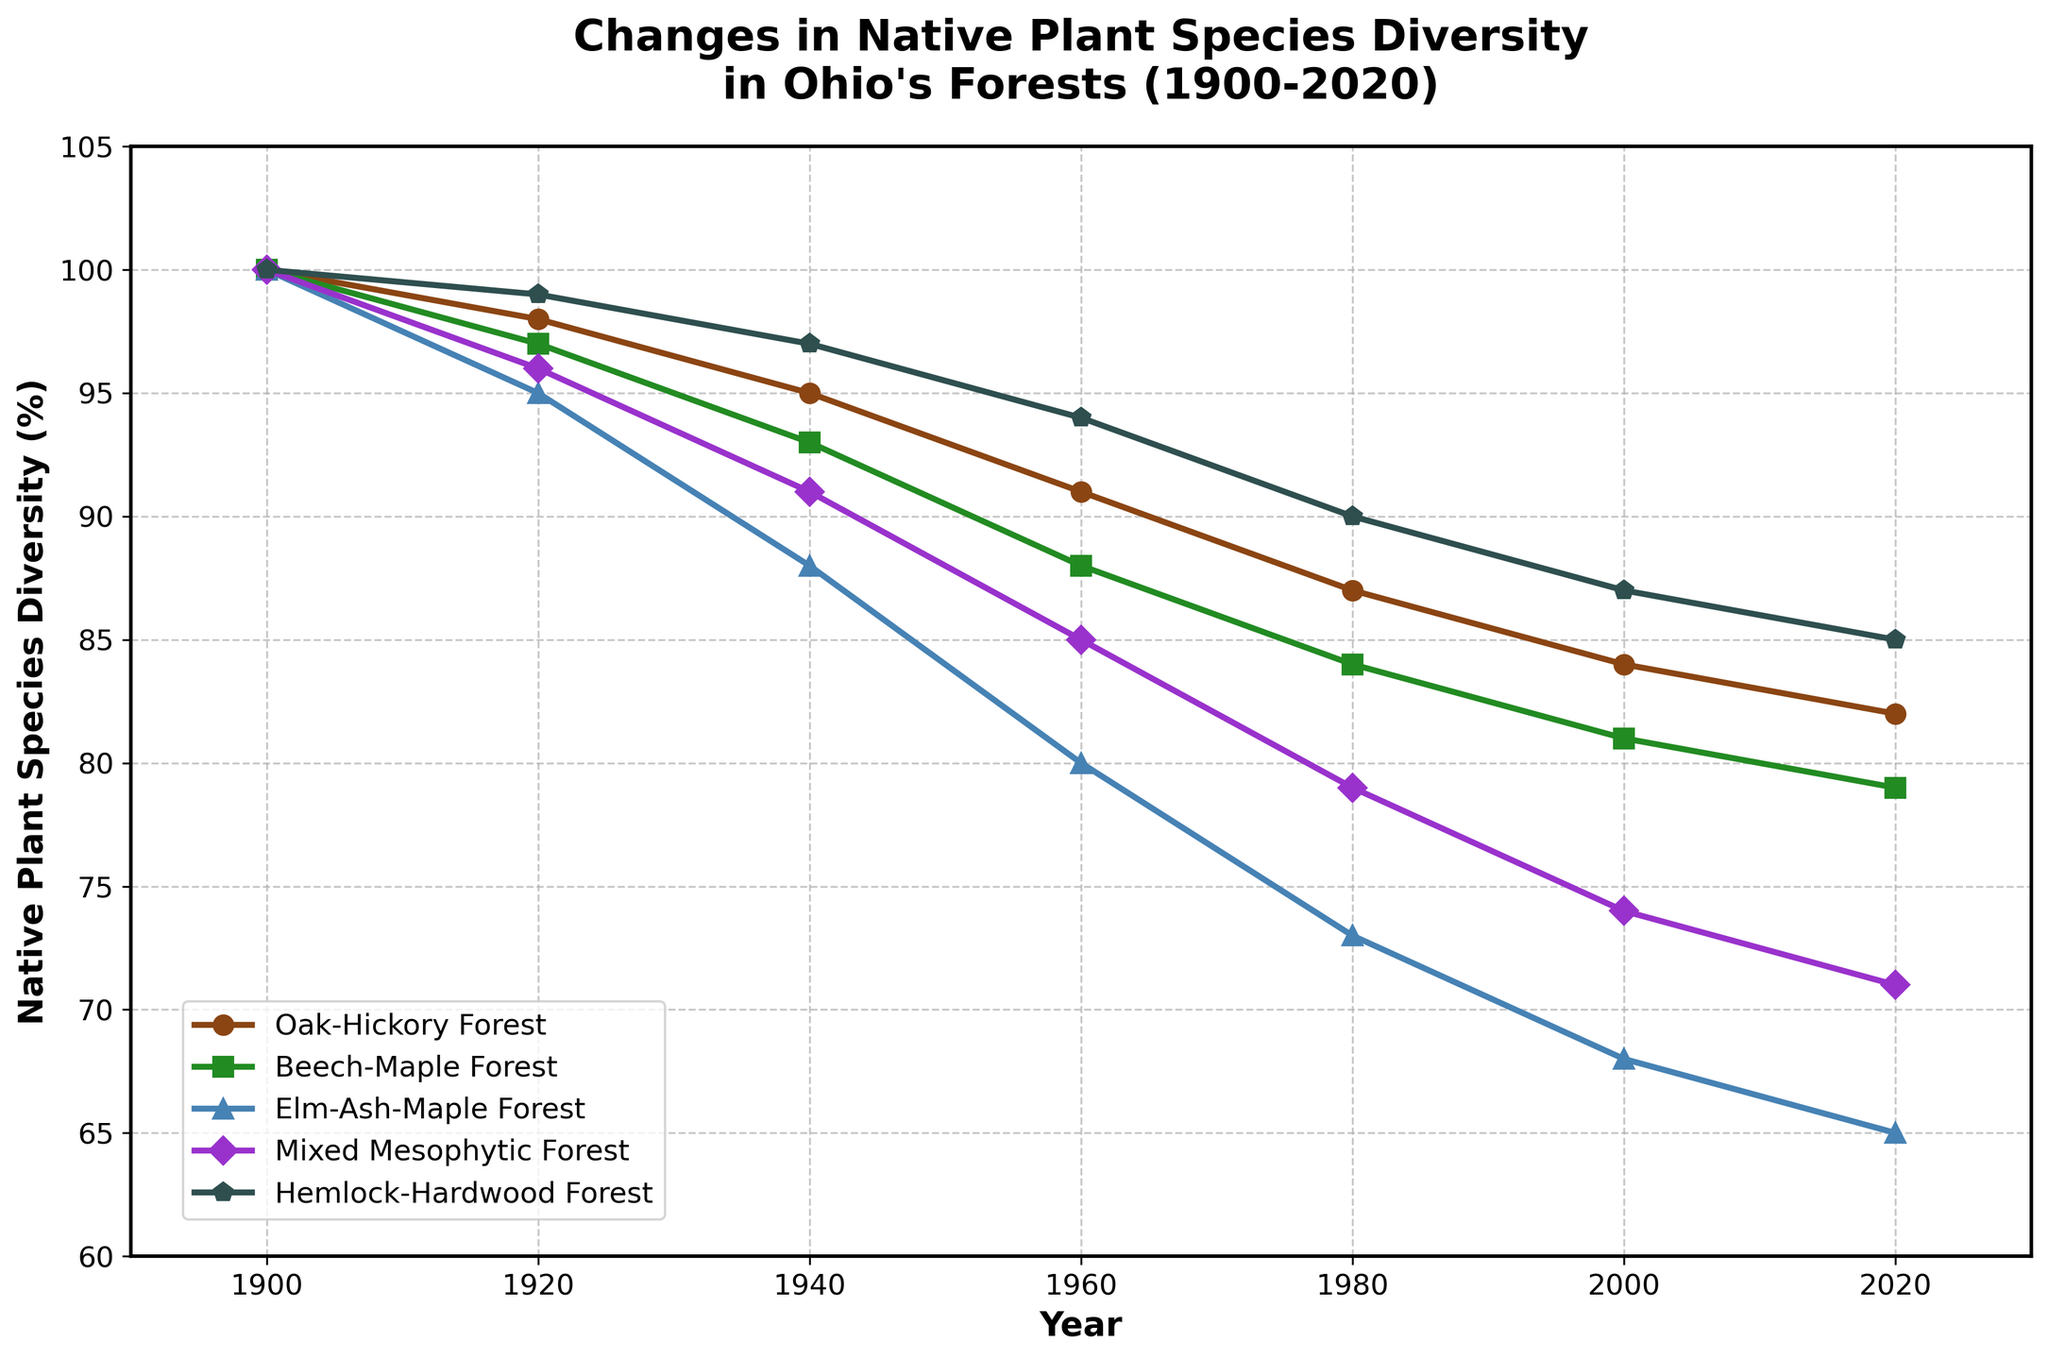Which forest type showed the least decrease in native plant species diversity from 1900 to 2020? To find the forest type with the least decrease in diversity, subtract each type's 2020 value from its 1900 value: Oak-Hickory (100-82=18), Beech-Maple (100-79=21), Elm-Ash-Maple (100-65=35), Mixed Mesophytic (100-71=29), Hemlock-Hardwood (100-85=15). The smallest decrease is for Hemlock-Hardwood Forest.
Answer: Hemlock-Hardwood Forest Which two forest types had the greatest difference in native plant species diversity in 2020? In 2020, the values are Oak-Hickory (82), Beech-Maple (79), Elm-Ash-Maple (65), Mixed Mesophytic (71), Hemlock-Hardwood (85). The greatest difference is between Hemlock-Hardwood (85) and Elm-Ash-Maple (65): 85 - 65 = 20.
Answer: Hemlock-Hardwood and Elm-Ash-Maple How did the diversity in Mixed Mesophytic Forest change from 1940 to 1960? From the plot, the values for 1940 and 1960 are 91% and 85% respectively. The change is calculated as 85 - 91 = -6%.
Answer: It decreased by 6% In which decade did the Oak-Hickory Forest experience the largest decrease in species diversity? Calculate the difference per decade: 1900-1920 (100-98=2), 1920-1940 (98-95=3), 1940-1960 (95-91=4), 1960-1980 (91-87=4), 1980-2000 (87-84=3), 2000-2020 (84-82=2). The largest decrease (4%) happened in two decades: 1940-1960 and 1960-1980.
Answer: 1940-1960 and 1960-1980 Which forest type showed a consistent decrease in diversity across all the decades? A consistent decrease means the value should decrease in each recorded year. Beech-Maple values are 100, 97, 93, 88, 84, 81, 79 for each decade, a consistent decrease across all years.
Answer: Beech-Maple Forest By how much did the Elm-Ash-Maple Forest diversity decrease from 1960 to 2020? Comparing the values for 1960 (80) and 2020 (65), calculate the decrease: 80 - 65 = 15.
Answer: 15% Which forest type had the highest diversity in 1980, and what was its value? In 1980, plot values are Oak-Hickory (87), Beech-Maple (84), Elm-Ash-Maple (73), Mixed Mesophytic (79), Hemlock-Hardwood (90). The highest value is for Hemlock-Hardwood Forest.
Answer: Hemlock-Hardwood Forest, 90% How much, on average, did the diversity decrease per decade for Oak-Hickory Forest from 1900 to 2020? Divide the change in diversity by the number of decades. Change from 1900 to 2020 is 100-82=18. There are 12 decades, thus 18/12 = 1.5% per decade.
Answer: 1.5% per decade What color represents Beech-Maple Forest in the plot? According to the legend, Beech-Maple Forest is represented by a green line.
Answer: Green 